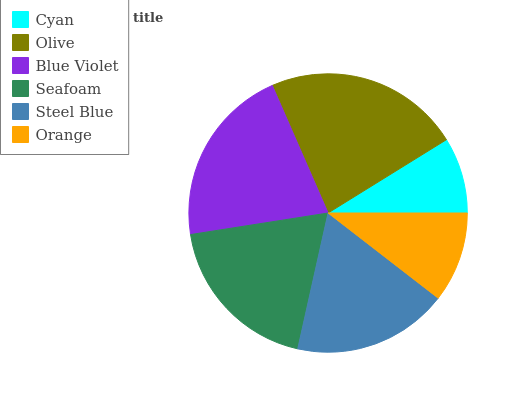Is Cyan the minimum?
Answer yes or no. Yes. Is Olive the maximum?
Answer yes or no. Yes. Is Blue Violet the minimum?
Answer yes or no. No. Is Blue Violet the maximum?
Answer yes or no. No. Is Olive greater than Blue Violet?
Answer yes or no. Yes. Is Blue Violet less than Olive?
Answer yes or no. Yes. Is Blue Violet greater than Olive?
Answer yes or no. No. Is Olive less than Blue Violet?
Answer yes or no. No. Is Seafoam the high median?
Answer yes or no. Yes. Is Steel Blue the low median?
Answer yes or no. Yes. Is Orange the high median?
Answer yes or no. No. Is Olive the low median?
Answer yes or no. No. 